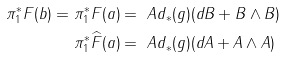<formula> <loc_0><loc_0><loc_500><loc_500>\pi _ { 1 } ^ { * } F ( b ) = \pi _ { 1 } ^ { * } F ( a ) & = \ A d _ { * } ( g ) ( d B + B \wedge B ) \\ \pi _ { 1 } ^ { * } \widehat { F } ( a ) & = \ A d _ { * } ( g ) ( d A + A \wedge A )</formula> 